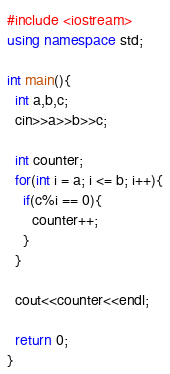Convert code to text. <code><loc_0><loc_0><loc_500><loc_500><_C++_>#include <iostream>
using namespace std;

int main(){
  int a,b,c;
  cin>>a>>b>>c;

  int counter;
  for(int i = a; i <= b; i++){
    if(c%i == 0){
      counter++;
    }
  }

  cout<<counter<<endl;

  return 0;
}</code> 